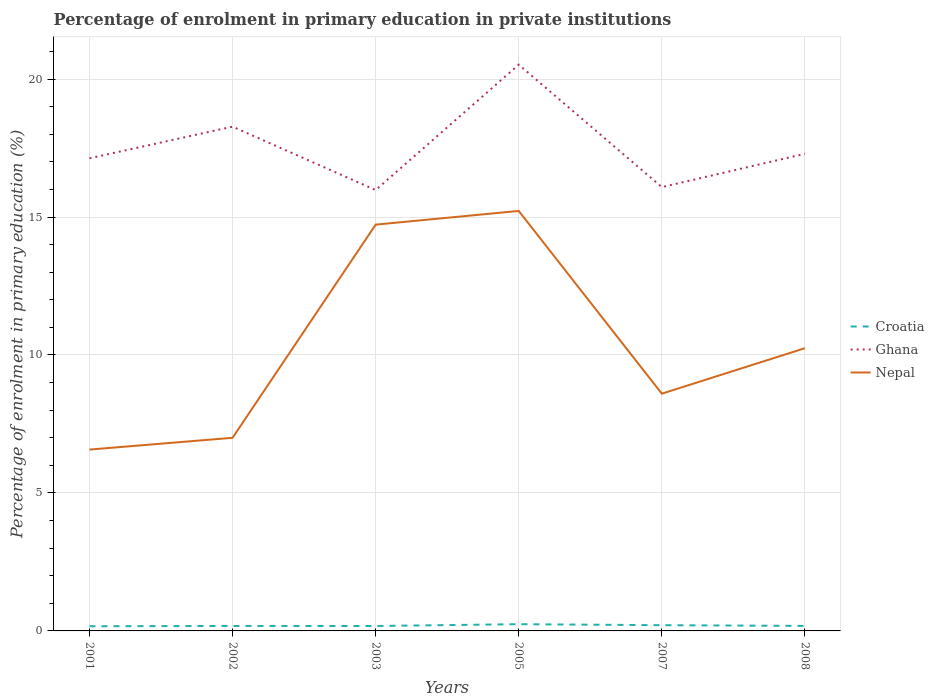Is the number of lines equal to the number of legend labels?
Offer a very short reply. Yes. Across all years, what is the maximum percentage of enrolment in primary education in Croatia?
Ensure brevity in your answer.  0.17. In which year was the percentage of enrolment in primary education in Nepal maximum?
Your response must be concise. 2001. What is the total percentage of enrolment in primary education in Ghana in the graph?
Provide a short and direct response. -4.55. What is the difference between the highest and the second highest percentage of enrolment in primary education in Croatia?
Ensure brevity in your answer.  0.07. What is the difference between the highest and the lowest percentage of enrolment in primary education in Ghana?
Offer a terse response. 2. How many lines are there?
Provide a succinct answer. 3. How many years are there in the graph?
Your response must be concise. 6. What is the difference between two consecutive major ticks on the Y-axis?
Your answer should be compact. 5. Are the values on the major ticks of Y-axis written in scientific E-notation?
Provide a short and direct response. No. Does the graph contain any zero values?
Provide a succinct answer. No. How many legend labels are there?
Give a very brief answer. 3. How are the legend labels stacked?
Your response must be concise. Vertical. What is the title of the graph?
Give a very brief answer. Percentage of enrolment in primary education in private institutions. What is the label or title of the Y-axis?
Your response must be concise. Percentage of enrolment in primary education (%). What is the Percentage of enrolment in primary education (%) in Croatia in 2001?
Your response must be concise. 0.17. What is the Percentage of enrolment in primary education (%) of Ghana in 2001?
Keep it short and to the point. 17.13. What is the Percentage of enrolment in primary education (%) of Nepal in 2001?
Make the answer very short. 6.57. What is the Percentage of enrolment in primary education (%) of Croatia in 2002?
Ensure brevity in your answer.  0.18. What is the Percentage of enrolment in primary education (%) in Ghana in 2002?
Offer a terse response. 18.28. What is the Percentage of enrolment in primary education (%) in Nepal in 2002?
Make the answer very short. 7. What is the Percentage of enrolment in primary education (%) in Croatia in 2003?
Ensure brevity in your answer.  0.18. What is the Percentage of enrolment in primary education (%) of Ghana in 2003?
Provide a short and direct response. 15.98. What is the Percentage of enrolment in primary education (%) in Nepal in 2003?
Give a very brief answer. 14.72. What is the Percentage of enrolment in primary education (%) of Croatia in 2005?
Make the answer very short. 0.24. What is the Percentage of enrolment in primary education (%) in Ghana in 2005?
Make the answer very short. 20.52. What is the Percentage of enrolment in primary education (%) in Nepal in 2005?
Offer a terse response. 15.22. What is the Percentage of enrolment in primary education (%) in Croatia in 2007?
Offer a very short reply. 0.21. What is the Percentage of enrolment in primary education (%) in Ghana in 2007?
Your answer should be very brief. 16.08. What is the Percentage of enrolment in primary education (%) of Nepal in 2007?
Offer a very short reply. 8.6. What is the Percentage of enrolment in primary education (%) in Croatia in 2008?
Your answer should be compact. 0.18. What is the Percentage of enrolment in primary education (%) in Ghana in 2008?
Provide a succinct answer. 17.29. What is the Percentage of enrolment in primary education (%) of Nepal in 2008?
Provide a short and direct response. 10.25. Across all years, what is the maximum Percentage of enrolment in primary education (%) in Croatia?
Provide a short and direct response. 0.24. Across all years, what is the maximum Percentage of enrolment in primary education (%) in Ghana?
Offer a terse response. 20.52. Across all years, what is the maximum Percentage of enrolment in primary education (%) in Nepal?
Provide a short and direct response. 15.22. Across all years, what is the minimum Percentage of enrolment in primary education (%) in Croatia?
Offer a very short reply. 0.17. Across all years, what is the minimum Percentage of enrolment in primary education (%) of Ghana?
Provide a succinct answer. 15.98. Across all years, what is the minimum Percentage of enrolment in primary education (%) of Nepal?
Keep it short and to the point. 6.57. What is the total Percentage of enrolment in primary education (%) in Croatia in the graph?
Your answer should be very brief. 1.16. What is the total Percentage of enrolment in primary education (%) in Ghana in the graph?
Your response must be concise. 105.28. What is the total Percentage of enrolment in primary education (%) of Nepal in the graph?
Give a very brief answer. 62.36. What is the difference between the Percentage of enrolment in primary education (%) in Croatia in 2001 and that in 2002?
Your response must be concise. -0.01. What is the difference between the Percentage of enrolment in primary education (%) in Ghana in 2001 and that in 2002?
Your answer should be compact. -1.15. What is the difference between the Percentage of enrolment in primary education (%) of Nepal in 2001 and that in 2002?
Your answer should be compact. -0.43. What is the difference between the Percentage of enrolment in primary education (%) in Croatia in 2001 and that in 2003?
Make the answer very short. -0.01. What is the difference between the Percentage of enrolment in primary education (%) of Ghana in 2001 and that in 2003?
Your response must be concise. 1.15. What is the difference between the Percentage of enrolment in primary education (%) of Nepal in 2001 and that in 2003?
Keep it short and to the point. -8.15. What is the difference between the Percentage of enrolment in primary education (%) in Croatia in 2001 and that in 2005?
Your answer should be very brief. -0.07. What is the difference between the Percentage of enrolment in primary education (%) of Ghana in 2001 and that in 2005?
Provide a short and direct response. -3.39. What is the difference between the Percentage of enrolment in primary education (%) of Nepal in 2001 and that in 2005?
Offer a terse response. -8.65. What is the difference between the Percentage of enrolment in primary education (%) in Croatia in 2001 and that in 2007?
Make the answer very short. -0.04. What is the difference between the Percentage of enrolment in primary education (%) in Ghana in 2001 and that in 2007?
Give a very brief answer. 1.04. What is the difference between the Percentage of enrolment in primary education (%) of Nepal in 2001 and that in 2007?
Provide a short and direct response. -2.03. What is the difference between the Percentage of enrolment in primary education (%) in Croatia in 2001 and that in 2008?
Offer a terse response. -0.01. What is the difference between the Percentage of enrolment in primary education (%) in Ghana in 2001 and that in 2008?
Offer a very short reply. -0.16. What is the difference between the Percentage of enrolment in primary education (%) in Nepal in 2001 and that in 2008?
Give a very brief answer. -3.67. What is the difference between the Percentage of enrolment in primary education (%) in Croatia in 2002 and that in 2003?
Your answer should be very brief. 0. What is the difference between the Percentage of enrolment in primary education (%) of Ghana in 2002 and that in 2003?
Keep it short and to the point. 2.3. What is the difference between the Percentage of enrolment in primary education (%) of Nepal in 2002 and that in 2003?
Your answer should be very brief. -7.73. What is the difference between the Percentage of enrolment in primary education (%) in Croatia in 2002 and that in 2005?
Provide a succinct answer. -0.06. What is the difference between the Percentage of enrolment in primary education (%) of Ghana in 2002 and that in 2005?
Provide a succinct answer. -2.25. What is the difference between the Percentage of enrolment in primary education (%) in Nepal in 2002 and that in 2005?
Provide a succinct answer. -8.22. What is the difference between the Percentage of enrolment in primary education (%) of Croatia in 2002 and that in 2007?
Make the answer very short. -0.03. What is the difference between the Percentage of enrolment in primary education (%) in Ghana in 2002 and that in 2007?
Provide a succinct answer. 2.19. What is the difference between the Percentage of enrolment in primary education (%) in Nepal in 2002 and that in 2007?
Offer a very short reply. -1.6. What is the difference between the Percentage of enrolment in primary education (%) of Croatia in 2002 and that in 2008?
Your answer should be very brief. -0. What is the difference between the Percentage of enrolment in primary education (%) of Ghana in 2002 and that in 2008?
Ensure brevity in your answer.  0.98. What is the difference between the Percentage of enrolment in primary education (%) of Nepal in 2002 and that in 2008?
Offer a terse response. -3.25. What is the difference between the Percentage of enrolment in primary education (%) of Croatia in 2003 and that in 2005?
Keep it short and to the point. -0.07. What is the difference between the Percentage of enrolment in primary education (%) of Ghana in 2003 and that in 2005?
Offer a terse response. -4.55. What is the difference between the Percentage of enrolment in primary education (%) of Nepal in 2003 and that in 2005?
Your response must be concise. -0.5. What is the difference between the Percentage of enrolment in primary education (%) in Croatia in 2003 and that in 2007?
Your answer should be very brief. -0.03. What is the difference between the Percentage of enrolment in primary education (%) in Ghana in 2003 and that in 2007?
Provide a succinct answer. -0.11. What is the difference between the Percentage of enrolment in primary education (%) of Nepal in 2003 and that in 2007?
Make the answer very short. 6.13. What is the difference between the Percentage of enrolment in primary education (%) in Croatia in 2003 and that in 2008?
Offer a very short reply. -0. What is the difference between the Percentage of enrolment in primary education (%) in Ghana in 2003 and that in 2008?
Make the answer very short. -1.31. What is the difference between the Percentage of enrolment in primary education (%) of Nepal in 2003 and that in 2008?
Offer a very short reply. 4.48. What is the difference between the Percentage of enrolment in primary education (%) in Croatia in 2005 and that in 2007?
Give a very brief answer. 0.04. What is the difference between the Percentage of enrolment in primary education (%) in Ghana in 2005 and that in 2007?
Provide a succinct answer. 4.44. What is the difference between the Percentage of enrolment in primary education (%) of Nepal in 2005 and that in 2007?
Your answer should be very brief. 6.62. What is the difference between the Percentage of enrolment in primary education (%) of Croatia in 2005 and that in 2008?
Provide a short and direct response. 0.06. What is the difference between the Percentage of enrolment in primary education (%) in Ghana in 2005 and that in 2008?
Your answer should be compact. 3.23. What is the difference between the Percentage of enrolment in primary education (%) in Nepal in 2005 and that in 2008?
Your answer should be compact. 4.97. What is the difference between the Percentage of enrolment in primary education (%) of Croatia in 2007 and that in 2008?
Make the answer very short. 0.03. What is the difference between the Percentage of enrolment in primary education (%) in Ghana in 2007 and that in 2008?
Your answer should be compact. -1.21. What is the difference between the Percentage of enrolment in primary education (%) in Nepal in 2007 and that in 2008?
Offer a terse response. -1.65. What is the difference between the Percentage of enrolment in primary education (%) of Croatia in 2001 and the Percentage of enrolment in primary education (%) of Ghana in 2002?
Make the answer very short. -18.11. What is the difference between the Percentage of enrolment in primary education (%) of Croatia in 2001 and the Percentage of enrolment in primary education (%) of Nepal in 2002?
Your answer should be very brief. -6.83. What is the difference between the Percentage of enrolment in primary education (%) in Ghana in 2001 and the Percentage of enrolment in primary education (%) in Nepal in 2002?
Provide a succinct answer. 10.13. What is the difference between the Percentage of enrolment in primary education (%) of Croatia in 2001 and the Percentage of enrolment in primary education (%) of Ghana in 2003?
Offer a terse response. -15.81. What is the difference between the Percentage of enrolment in primary education (%) of Croatia in 2001 and the Percentage of enrolment in primary education (%) of Nepal in 2003?
Your response must be concise. -14.56. What is the difference between the Percentage of enrolment in primary education (%) of Ghana in 2001 and the Percentage of enrolment in primary education (%) of Nepal in 2003?
Offer a terse response. 2.4. What is the difference between the Percentage of enrolment in primary education (%) in Croatia in 2001 and the Percentage of enrolment in primary education (%) in Ghana in 2005?
Make the answer very short. -20.35. What is the difference between the Percentage of enrolment in primary education (%) in Croatia in 2001 and the Percentage of enrolment in primary education (%) in Nepal in 2005?
Keep it short and to the point. -15.05. What is the difference between the Percentage of enrolment in primary education (%) in Ghana in 2001 and the Percentage of enrolment in primary education (%) in Nepal in 2005?
Make the answer very short. 1.91. What is the difference between the Percentage of enrolment in primary education (%) of Croatia in 2001 and the Percentage of enrolment in primary education (%) of Ghana in 2007?
Keep it short and to the point. -15.91. What is the difference between the Percentage of enrolment in primary education (%) of Croatia in 2001 and the Percentage of enrolment in primary education (%) of Nepal in 2007?
Offer a very short reply. -8.43. What is the difference between the Percentage of enrolment in primary education (%) in Ghana in 2001 and the Percentage of enrolment in primary education (%) in Nepal in 2007?
Keep it short and to the point. 8.53. What is the difference between the Percentage of enrolment in primary education (%) in Croatia in 2001 and the Percentage of enrolment in primary education (%) in Ghana in 2008?
Provide a short and direct response. -17.12. What is the difference between the Percentage of enrolment in primary education (%) of Croatia in 2001 and the Percentage of enrolment in primary education (%) of Nepal in 2008?
Your answer should be compact. -10.08. What is the difference between the Percentage of enrolment in primary education (%) in Ghana in 2001 and the Percentage of enrolment in primary education (%) in Nepal in 2008?
Ensure brevity in your answer.  6.88. What is the difference between the Percentage of enrolment in primary education (%) of Croatia in 2002 and the Percentage of enrolment in primary education (%) of Ghana in 2003?
Keep it short and to the point. -15.8. What is the difference between the Percentage of enrolment in primary education (%) in Croatia in 2002 and the Percentage of enrolment in primary education (%) in Nepal in 2003?
Offer a very short reply. -14.54. What is the difference between the Percentage of enrolment in primary education (%) in Ghana in 2002 and the Percentage of enrolment in primary education (%) in Nepal in 2003?
Make the answer very short. 3.55. What is the difference between the Percentage of enrolment in primary education (%) of Croatia in 2002 and the Percentage of enrolment in primary education (%) of Ghana in 2005?
Provide a succinct answer. -20.34. What is the difference between the Percentage of enrolment in primary education (%) in Croatia in 2002 and the Percentage of enrolment in primary education (%) in Nepal in 2005?
Ensure brevity in your answer.  -15.04. What is the difference between the Percentage of enrolment in primary education (%) of Ghana in 2002 and the Percentage of enrolment in primary education (%) of Nepal in 2005?
Provide a short and direct response. 3.05. What is the difference between the Percentage of enrolment in primary education (%) of Croatia in 2002 and the Percentage of enrolment in primary education (%) of Ghana in 2007?
Offer a terse response. -15.9. What is the difference between the Percentage of enrolment in primary education (%) in Croatia in 2002 and the Percentage of enrolment in primary education (%) in Nepal in 2007?
Provide a short and direct response. -8.42. What is the difference between the Percentage of enrolment in primary education (%) of Ghana in 2002 and the Percentage of enrolment in primary education (%) of Nepal in 2007?
Your answer should be compact. 9.68. What is the difference between the Percentage of enrolment in primary education (%) in Croatia in 2002 and the Percentage of enrolment in primary education (%) in Ghana in 2008?
Your response must be concise. -17.11. What is the difference between the Percentage of enrolment in primary education (%) in Croatia in 2002 and the Percentage of enrolment in primary education (%) in Nepal in 2008?
Offer a terse response. -10.07. What is the difference between the Percentage of enrolment in primary education (%) in Ghana in 2002 and the Percentage of enrolment in primary education (%) in Nepal in 2008?
Ensure brevity in your answer.  8.03. What is the difference between the Percentage of enrolment in primary education (%) in Croatia in 2003 and the Percentage of enrolment in primary education (%) in Ghana in 2005?
Your response must be concise. -20.34. What is the difference between the Percentage of enrolment in primary education (%) in Croatia in 2003 and the Percentage of enrolment in primary education (%) in Nepal in 2005?
Offer a very short reply. -15.04. What is the difference between the Percentage of enrolment in primary education (%) of Ghana in 2003 and the Percentage of enrolment in primary education (%) of Nepal in 2005?
Keep it short and to the point. 0.76. What is the difference between the Percentage of enrolment in primary education (%) of Croatia in 2003 and the Percentage of enrolment in primary education (%) of Ghana in 2007?
Keep it short and to the point. -15.91. What is the difference between the Percentage of enrolment in primary education (%) in Croatia in 2003 and the Percentage of enrolment in primary education (%) in Nepal in 2007?
Provide a succinct answer. -8.42. What is the difference between the Percentage of enrolment in primary education (%) in Ghana in 2003 and the Percentage of enrolment in primary education (%) in Nepal in 2007?
Offer a very short reply. 7.38. What is the difference between the Percentage of enrolment in primary education (%) of Croatia in 2003 and the Percentage of enrolment in primary education (%) of Ghana in 2008?
Give a very brief answer. -17.11. What is the difference between the Percentage of enrolment in primary education (%) of Croatia in 2003 and the Percentage of enrolment in primary education (%) of Nepal in 2008?
Make the answer very short. -10.07. What is the difference between the Percentage of enrolment in primary education (%) in Ghana in 2003 and the Percentage of enrolment in primary education (%) in Nepal in 2008?
Ensure brevity in your answer.  5.73. What is the difference between the Percentage of enrolment in primary education (%) in Croatia in 2005 and the Percentage of enrolment in primary education (%) in Ghana in 2007?
Make the answer very short. -15.84. What is the difference between the Percentage of enrolment in primary education (%) of Croatia in 2005 and the Percentage of enrolment in primary education (%) of Nepal in 2007?
Make the answer very short. -8.35. What is the difference between the Percentage of enrolment in primary education (%) in Ghana in 2005 and the Percentage of enrolment in primary education (%) in Nepal in 2007?
Ensure brevity in your answer.  11.92. What is the difference between the Percentage of enrolment in primary education (%) of Croatia in 2005 and the Percentage of enrolment in primary education (%) of Ghana in 2008?
Provide a short and direct response. -17.05. What is the difference between the Percentage of enrolment in primary education (%) in Croatia in 2005 and the Percentage of enrolment in primary education (%) in Nepal in 2008?
Keep it short and to the point. -10. What is the difference between the Percentage of enrolment in primary education (%) in Ghana in 2005 and the Percentage of enrolment in primary education (%) in Nepal in 2008?
Make the answer very short. 10.28. What is the difference between the Percentage of enrolment in primary education (%) of Croatia in 2007 and the Percentage of enrolment in primary education (%) of Ghana in 2008?
Offer a terse response. -17.08. What is the difference between the Percentage of enrolment in primary education (%) of Croatia in 2007 and the Percentage of enrolment in primary education (%) of Nepal in 2008?
Provide a short and direct response. -10.04. What is the difference between the Percentage of enrolment in primary education (%) of Ghana in 2007 and the Percentage of enrolment in primary education (%) of Nepal in 2008?
Provide a succinct answer. 5.84. What is the average Percentage of enrolment in primary education (%) in Croatia per year?
Offer a very short reply. 0.19. What is the average Percentage of enrolment in primary education (%) of Ghana per year?
Give a very brief answer. 17.55. What is the average Percentage of enrolment in primary education (%) in Nepal per year?
Offer a terse response. 10.39. In the year 2001, what is the difference between the Percentage of enrolment in primary education (%) in Croatia and Percentage of enrolment in primary education (%) in Ghana?
Your response must be concise. -16.96. In the year 2001, what is the difference between the Percentage of enrolment in primary education (%) of Croatia and Percentage of enrolment in primary education (%) of Nepal?
Your response must be concise. -6.4. In the year 2001, what is the difference between the Percentage of enrolment in primary education (%) of Ghana and Percentage of enrolment in primary education (%) of Nepal?
Offer a terse response. 10.56. In the year 2002, what is the difference between the Percentage of enrolment in primary education (%) of Croatia and Percentage of enrolment in primary education (%) of Ghana?
Ensure brevity in your answer.  -18.1. In the year 2002, what is the difference between the Percentage of enrolment in primary education (%) of Croatia and Percentage of enrolment in primary education (%) of Nepal?
Offer a very short reply. -6.82. In the year 2002, what is the difference between the Percentage of enrolment in primary education (%) of Ghana and Percentage of enrolment in primary education (%) of Nepal?
Give a very brief answer. 11.28. In the year 2003, what is the difference between the Percentage of enrolment in primary education (%) in Croatia and Percentage of enrolment in primary education (%) in Ghana?
Provide a succinct answer. -15.8. In the year 2003, what is the difference between the Percentage of enrolment in primary education (%) of Croatia and Percentage of enrolment in primary education (%) of Nepal?
Ensure brevity in your answer.  -14.55. In the year 2003, what is the difference between the Percentage of enrolment in primary education (%) in Ghana and Percentage of enrolment in primary education (%) in Nepal?
Provide a succinct answer. 1.25. In the year 2005, what is the difference between the Percentage of enrolment in primary education (%) of Croatia and Percentage of enrolment in primary education (%) of Ghana?
Your answer should be compact. -20.28. In the year 2005, what is the difference between the Percentage of enrolment in primary education (%) in Croatia and Percentage of enrolment in primary education (%) in Nepal?
Your answer should be very brief. -14.98. In the year 2005, what is the difference between the Percentage of enrolment in primary education (%) of Ghana and Percentage of enrolment in primary education (%) of Nepal?
Provide a succinct answer. 5.3. In the year 2007, what is the difference between the Percentage of enrolment in primary education (%) in Croatia and Percentage of enrolment in primary education (%) in Ghana?
Your answer should be very brief. -15.88. In the year 2007, what is the difference between the Percentage of enrolment in primary education (%) of Croatia and Percentage of enrolment in primary education (%) of Nepal?
Keep it short and to the point. -8.39. In the year 2007, what is the difference between the Percentage of enrolment in primary education (%) of Ghana and Percentage of enrolment in primary education (%) of Nepal?
Provide a succinct answer. 7.49. In the year 2008, what is the difference between the Percentage of enrolment in primary education (%) of Croatia and Percentage of enrolment in primary education (%) of Ghana?
Your answer should be compact. -17.11. In the year 2008, what is the difference between the Percentage of enrolment in primary education (%) of Croatia and Percentage of enrolment in primary education (%) of Nepal?
Provide a short and direct response. -10.06. In the year 2008, what is the difference between the Percentage of enrolment in primary education (%) of Ghana and Percentage of enrolment in primary education (%) of Nepal?
Your answer should be compact. 7.04. What is the ratio of the Percentage of enrolment in primary education (%) of Croatia in 2001 to that in 2002?
Offer a very short reply. 0.94. What is the ratio of the Percentage of enrolment in primary education (%) of Ghana in 2001 to that in 2002?
Offer a very short reply. 0.94. What is the ratio of the Percentage of enrolment in primary education (%) in Nepal in 2001 to that in 2002?
Your answer should be very brief. 0.94. What is the ratio of the Percentage of enrolment in primary education (%) of Croatia in 2001 to that in 2003?
Your answer should be very brief. 0.95. What is the ratio of the Percentage of enrolment in primary education (%) in Ghana in 2001 to that in 2003?
Ensure brevity in your answer.  1.07. What is the ratio of the Percentage of enrolment in primary education (%) in Nepal in 2001 to that in 2003?
Your response must be concise. 0.45. What is the ratio of the Percentage of enrolment in primary education (%) of Croatia in 2001 to that in 2005?
Offer a terse response. 0.69. What is the ratio of the Percentage of enrolment in primary education (%) in Ghana in 2001 to that in 2005?
Your answer should be compact. 0.83. What is the ratio of the Percentage of enrolment in primary education (%) of Nepal in 2001 to that in 2005?
Your response must be concise. 0.43. What is the ratio of the Percentage of enrolment in primary education (%) of Croatia in 2001 to that in 2007?
Your response must be concise. 0.81. What is the ratio of the Percentage of enrolment in primary education (%) of Ghana in 2001 to that in 2007?
Provide a short and direct response. 1.06. What is the ratio of the Percentage of enrolment in primary education (%) of Nepal in 2001 to that in 2007?
Make the answer very short. 0.76. What is the ratio of the Percentage of enrolment in primary education (%) in Croatia in 2001 to that in 2008?
Your response must be concise. 0.93. What is the ratio of the Percentage of enrolment in primary education (%) of Ghana in 2001 to that in 2008?
Your response must be concise. 0.99. What is the ratio of the Percentage of enrolment in primary education (%) in Nepal in 2001 to that in 2008?
Offer a very short reply. 0.64. What is the ratio of the Percentage of enrolment in primary education (%) in Croatia in 2002 to that in 2003?
Provide a succinct answer. 1.01. What is the ratio of the Percentage of enrolment in primary education (%) in Ghana in 2002 to that in 2003?
Keep it short and to the point. 1.14. What is the ratio of the Percentage of enrolment in primary education (%) of Nepal in 2002 to that in 2003?
Make the answer very short. 0.48. What is the ratio of the Percentage of enrolment in primary education (%) of Croatia in 2002 to that in 2005?
Make the answer very short. 0.74. What is the ratio of the Percentage of enrolment in primary education (%) of Ghana in 2002 to that in 2005?
Keep it short and to the point. 0.89. What is the ratio of the Percentage of enrolment in primary education (%) of Nepal in 2002 to that in 2005?
Provide a short and direct response. 0.46. What is the ratio of the Percentage of enrolment in primary education (%) of Croatia in 2002 to that in 2007?
Your response must be concise. 0.87. What is the ratio of the Percentage of enrolment in primary education (%) in Ghana in 2002 to that in 2007?
Offer a very short reply. 1.14. What is the ratio of the Percentage of enrolment in primary education (%) in Nepal in 2002 to that in 2007?
Give a very brief answer. 0.81. What is the ratio of the Percentage of enrolment in primary education (%) in Croatia in 2002 to that in 2008?
Your response must be concise. 0.99. What is the ratio of the Percentage of enrolment in primary education (%) in Ghana in 2002 to that in 2008?
Your answer should be compact. 1.06. What is the ratio of the Percentage of enrolment in primary education (%) in Nepal in 2002 to that in 2008?
Offer a very short reply. 0.68. What is the ratio of the Percentage of enrolment in primary education (%) in Croatia in 2003 to that in 2005?
Make the answer very short. 0.73. What is the ratio of the Percentage of enrolment in primary education (%) of Ghana in 2003 to that in 2005?
Provide a succinct answer. 0.78. What is the ratio of the Percentage of enrolment in primary education (%) of Nepal in 2003 to that in 2005?
Your response must be concise. 0.97. What is the ratio of the Percentage of enrolment in primary education (%) in Croatia in 2003 to that in 2007?
Your response must be concise. 0.86. What is the ratio of the Percentage of enrolment in primary education (%) of Nepal in 2003 to that in 2007?
Offer a very short reply. 1.71. What is the ratio of the Percentage of enrolment in primary education (%) of Croatia in 2003 to that in 2008?
Provide a short and direct response. 0.98. What is the ratio of the Percentage of enrolment in primary education (%) of Ghana in 2003 to that in 2008?
Provide a short and direct response. 0.92. What is the ratio of the Percentage of enrolment in primary education (%) of Nepal in 2003 to that in 2008?
Provide a succinct answer. 1.44. What is the ratio of the Percentage of enrolment in primary education (%) in Croatia in 2005 to that in 2007?
Offer a terse response. 1.18. What is the ratio of the Percentage of enrolment in primary education (%) in Ghana in 2005 to that in 2007?
Your response must be concise. 1.28. What is the ratio of the Percentage of enrolment in primary education (%) in Nepal in 2005 to that in 2007?
Your answer should be very brief. 1.77. What is the ratio of the Percentage of enrolment in primary education (%) of Croatia in 2005 to that in 2008?
Your response must be concise. 1.34. What is the ratio of the Percentage of enrolment in primary education (%) of Ghana in 2005 to that in 2008?
Your answer should be very brief. 1.19. What is the ratio of the Percentage of enrolment in primary education (%) of Nepal in 2005 to that in 2008?
Your response must be concise. 1.49. What is the ratio of the Percentage of enrolment in primary education (%) of Croatia in 2007 to that in 2008?
Offer a terse response. 1.14. What is the ratio of the Percentage of enrolment in primary education (%) in Ghana in 2007 to that in 2008?
Make the answer very short. 0.93. What is the ratio of the Percentage of enrolment in primary education (%) in Nepal in 2007 to that in 2008?
Provide a short and direct response. 0.84. What is the difference between the highest and the second highest Percentage of enrolment in primary education (%) of Croatia?
Your answer should be very brief. 0.04. What is the difference between the highest and the second highest Percentage of enrolment in primary education (%) of Ghana?
Offer a very short reply. 2.25. What is the difference between the highest and the second highest Percentage of enrolment in primary education (%) of Nepal?
Provide a succinct answer. 0.5. What is the difference between the highest and the lowest Percentage of enrolment in primary education (%) of Croatia?
Your answer should be compact. 0.07. What is the difference between the highest and the lowest Percentage of enrolment in primary education (%) in Ghana?
Your response must be concise. 4.55. What is the difference between the highest and the lowest Percentage of enrolment in primary education (%) of Nepal?
Your answer should be compact. 8.65. 